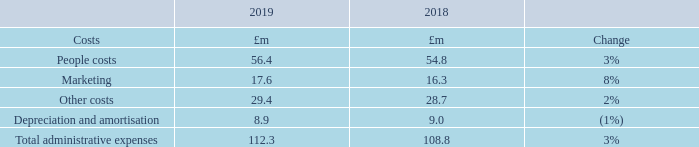Administrative expenses
The Group has adopted IFRS 16 ‘Leases’ in the period, which impacts Other costs and Depreciation & amortisation within Operating profit. Property and vehicle rental charges are no longer included in other costs, and depreciation now includes depreciation on leased assets. Prior period comparatives have been restated to reflect these changes as the fully retrospective approach has been used.
Operating costs continue to be well controlled, with administrative expenses increasing by 3% to £112.3m (2018 restated: £108.8m).
People costs, which comprise all staff costs including third-party contractor costs, increased by 3% in the year to £56.4m (2018: £54.8m). The increase in people costs was driven primarily by underlying salary costs which increased due to strong competition for digital talent, however this has been partially offset by a reduction in average full-time equivalent employees (‘FTEs’) (including contractors) to 804 (2018: 824). The number of FTEs was particularly impacted in the fourth quarter by the transfer of 15 staff to Dealer Auction, our joint venture with Cox Automotive UK. Share-based payments, including applicable national insurance costs of £5.9m (2018: £3.7m), have been included within people costs. The year-on-year increase in the share-based payment charge was due to leavers under the Performance Share Plan in 2018 for which a credit was recognised in the prior year, and a change in the way senior management are remunerated. The Group now settles a greater proportion of the senior management incentive scheme in shares which increases the share-based payment charge with an offset realised within cash bonuses.
Marketing spend increased in line with revenue by 8% to £17.6m (2018: £16.3m), as we look to maintain and enhance our audience position and educate consumers on new products such as new car offerings and search by monthly payment.
Other costs, which include data services, property related costs and other overheads, remain well controlled and increased by 2% on a like-for-like basis to £29.4m (2018 restated: £28.7m).
Depreciation & amortisation remained broadly flat at £8.9m (2018 restated: £9.0m). Within this was depreciation of £2.0m in relation to lease assets (2018 restated: £1.9m).
1    2018 has been restated for the impact of IFRS 16.
What are the total administrative expenses in 2019? £112.3m. What are Marketing costs in 2019? £17.6m. What are the components factored in when calculating the total administrative expenses? People costs, marketing, other costs, depreciation and amortisation. In which year was Depreciation and amortisation larger? 9.0>8.9
Answer: 2018. What was the change in Other costs in 2019 from 2018?
Answer scale should be: million. 29.4-28.7
Answer: 0.7. What was the average Total administrative expenses in 2018 and 2019?
Answer scale should be: million. (112.3+108.8)/2
Answer: 110.55. 